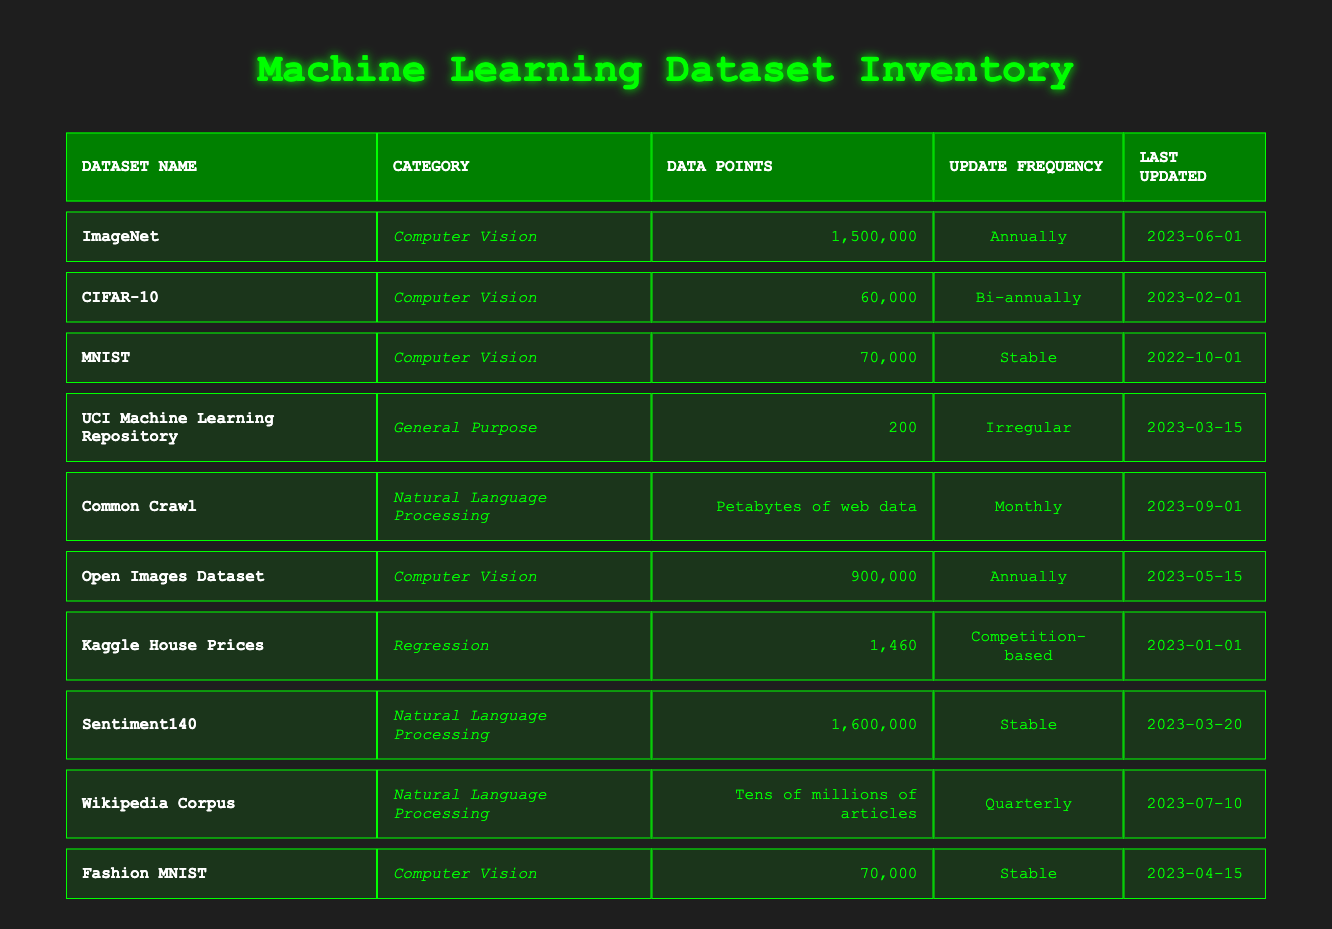What is the dataset with the highest number of data points? The dataset with the highest number of data points is ImageNet, which has 1,500,000 data points. This can be determined by comparing the "data_points" values in each row; ImageNet stands out as the maximum value.
Answer: ImageNet Which dataset was last updated in June 2023? The "last_updated" column shows that ImageNet was last updated on June 1, 2023. This information can be directly retrieved from the corresponding row.
Answer: ImageNet How many datasets fall under the category of Natural Language Processing? By counting the entries classified under "Natural Language Processing," we find three datasets: Common Crawl, Sentiment140, and Wikipedia Corpus.
Answer: Three Is the UCI Machine Learning Repository updated regularly? The update frequency for the UCI Machine Learning Repository is indicated as "Irregular," which means it does not follow a regular schedule. Therefore, the statement is false.
Answer: No What is the sum of data points for datasets categorized under Computer Vision? The total data points for Computer Vision datasets include: ImageNet (1,500,000) + CIFAR-10 (60,000) + MNIST (70,000) + Open Images Dataset (900,000) + Fashion MNIST (70,000). Adding these gives: 1,500,000 + 60,000 + 70,000 + 900,000 + 70,000 = 2,600,000.
Answer: 2,600,000 Which dataset has the latest update date, and what is that date? When looking through the "last_updated" column for the most recent date, we find that Common Crawl has the latest date of September 1, 2023, indicating it is the most current dataset.
Answer: Common Crawl, September 1, 2023 Is Fashion MNIST updated more frequently than once a year? Fashion MNIST is noted as having a "Stable" update frequency, which implies it is not updated more than once a year. Hence, the answer is false.
Answer: No What is the average number of data points for datasets in the Regression category? There is only one dataset in the Regression category, which is Kaggle House Prices with 1,460 data points. As such, the average number of data points is simply 1,460 since there are no additional data points to average out with.
Answer: 1,460 